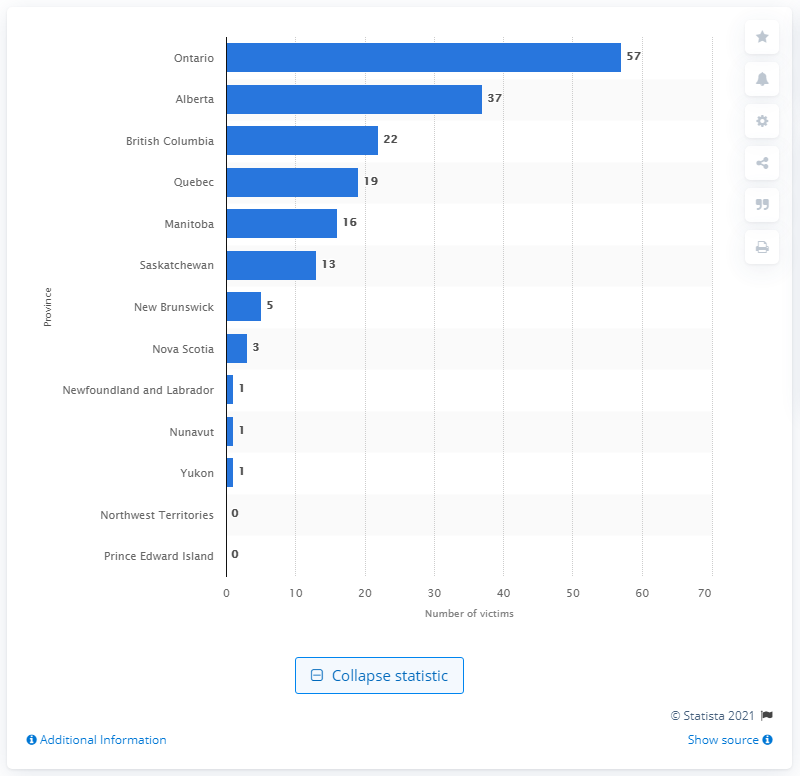Point out several critical features in this image. There were 57 reported stabbing homicide victims in Ontario in 2016. 